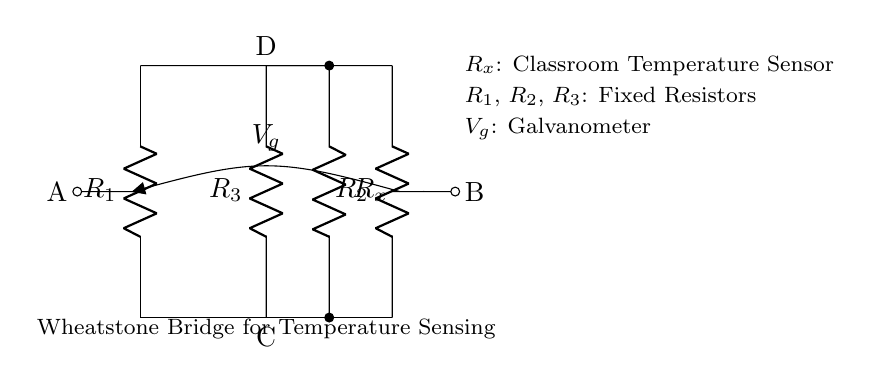What do the resistors R1, R2, and R3 represent? R1, R2, and R3 are fixed resistors used to balance the Wheatstone bridge circuit. They set a standard against which the unknown resistor RX is measured.
Answer: Fixed resistors What does RX represent in this circuit? RX is the classroom temperature sensor, which changes its resistance based on the temperature of the classroom. Its resistance value is compared to the fixed resistors to determine the temperature.
Answer: Classroom temperature sensor What is the purpose of the galvanometer in this circuit? The galvanometer measures the null point of the bridge, indicating whether the bridge is balanced or if there is a difference in voltage between the two points A and B. A zero reading means the circuit is balanced and RX is equal to the combined resistance of R1, R2, and R3 in a specific ratio.
Answer: Measure voltage difference What are the terminals A and B used for? Terminals A and B are connection points across which the voltage generated by the galvanometer is measured. They help in determining the balance condition of the Wheatstone bridge and indirectly the value of RX.
Answer: Connection points How does the Wheatstone bridge indicate the temperature? The Wheatstone bridge indicates temperature by measuring the balance of the resistances. When the temperature varies, RX changes its resistance, which then either causes current to flow through the galvanometer or remains at zero, allowing the calculation of temperature based on the voltage differences.
Answer: By measuring resistance What happens if RX increases? If RX increases, the bridge may become unbalanced if R1, R2, and R3 remain constant. This would be indicated by a non-zero reading on the galvanometer, signifying a change in temperature and thus a change in resistance.
Answer: Galvanometer reading changes What method is used to detect balance in the Wheatstone bridge? The balance is detected by the galvanometer, which will show a zero reading when the bridge is balanced, meaning that the ratio of resistances R1, R2, and R3 is equal to the ratio of RX when there is no current through the galvanometer.
Answer: Galvanometer reading 